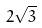<formula> <loc_0><loc_0><loc_500><loc_500>2 \sqrt { 3 }</formula> 